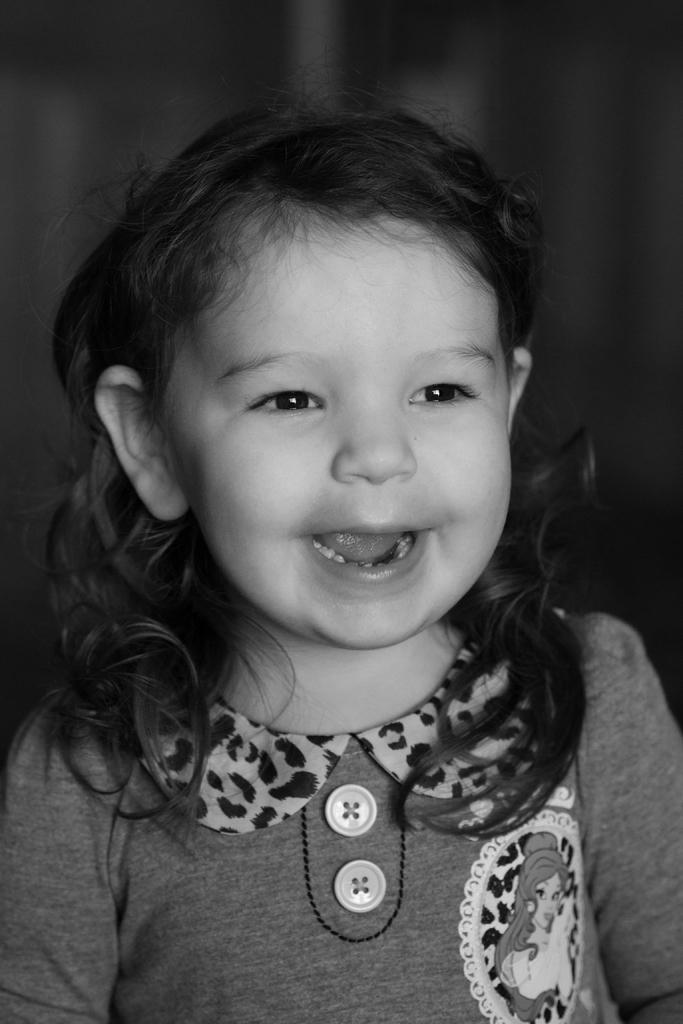Who is the main subject in the image? There is a girl in the image. What is the girl doing in the image? The girl is smiling in the image. What color is the background of the image? The background of the image is black. What type of pancake is the girl holding in the image? There is no pancake present in the image; the girl is simply smiling. 